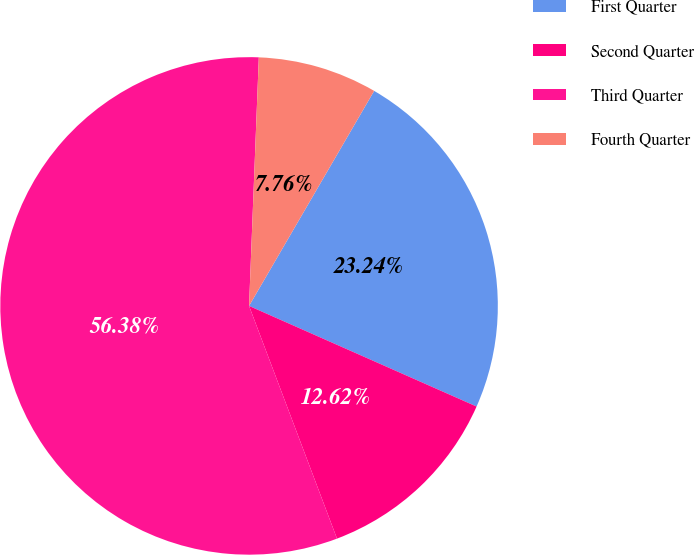Convert chart to OTSL. <chart><loc_0><loc_0><loc_500><loc_500><pie_chart><fcel>First Quarter<fcel>Second Quarter<fcel>Third Quarter<fcel>Fourth Quarter<nl><fcel>23.24%<fcel>12.62%<fcel>56.37%<fcel>7.76%<nl></chart> 